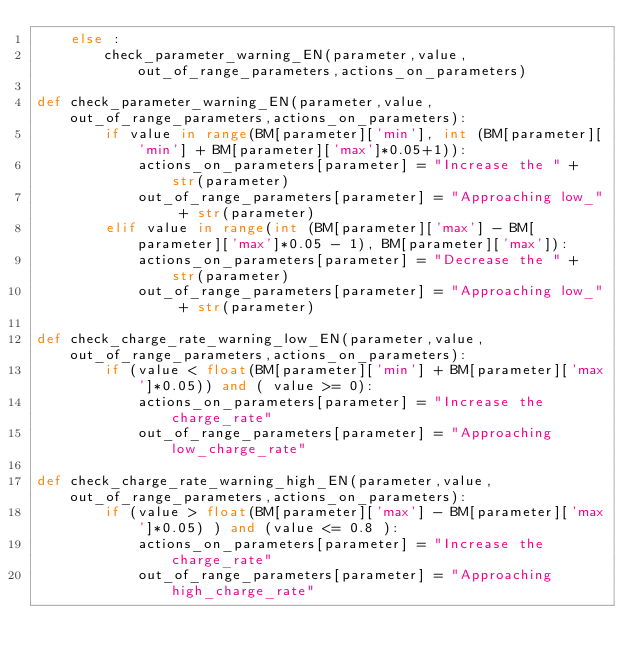<code> <loc_0><loc_0><loc_500><loc_500><_Python_>	else :
		check_parameter_warning_EN(parameter,value,out_of_range_parameters,actions_on_parameters)

def check_parameter_warning_EN(parameter,value,out_of_range_parameters,actions_on_parameters):
        if value in range(BM[parameter]['min'], int (BM[parameter]['min'] + BM[parameter]['max']*0.05+1)):
            actions_on_parameters[parameter] = "Increase the " + str(parameter)
            out_of_range_parameters[parameter] = "Approaching low_" + str(parameter)
        elif value in range(int (BM[parameter]['max'] - BM[parameter]['max']*0.05 - 1), BM[parameter]['max']):
            actions_on_parameters[parameter] = "Decrease the " + str(parameter)
            out_of_range_parameters[parameter] = "Approaching low_" + str(parameter)

def check_charge_rate_warning_low_EN(parameter,value,out_of_range_parameters,actions_on_parameters):
        if (value < float(BM[parameter]['min'] + BM[parameter]['max']*0.05)) and ( value >= 0):
            actions_on_parameters[parameter] = "Increase the charge_rate"
            out_of_range_parameters[parameter] = "Approaching low_charge_rate"

def check_charge_rate_warning_high_EN(parameter,value,out_of_range_parameters,actions_on_parameters):
		if (value > float(BM[parameter]['max'] - BM[parameter]['max']*0.05) ) and (value <= 0.8 ):
			actions_on_parameters[parameter] = "Increase the charge_rate"
			out_of_range_parameters[parameter] = "Approaching high_charge_rate"</code> 